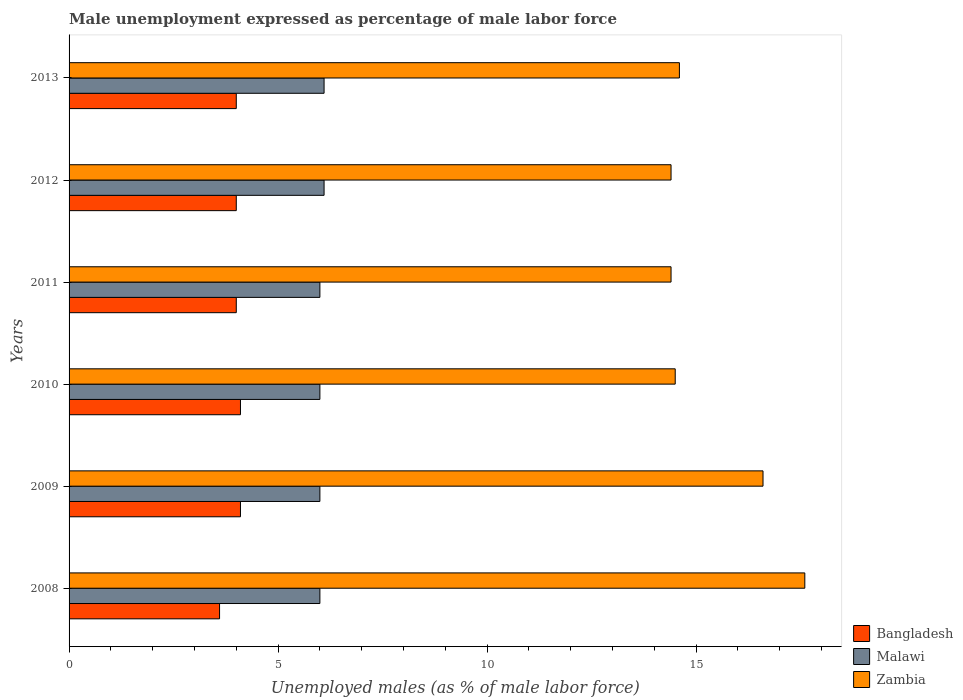How many different coloured bars are there?
Your answer should be very brief. 3. How many groups of bars are there?
Your response must be concise. 6. Are the number of bars on each tick of the Y-axis equal?
Your answer should be very brief. Yes. How many bars are there on the 2nd tick from the bottom?
Your response must be concise. 3. What is the label of the 3rd group of bars from the top?
Provide a short and direct response. 2011. What is the unemployment in males in in Zambia in 2011?
Your answer should be very brief. 14.4. Across all years, what is the maximum unemployment in males in in Zambia?
Your answer should be compact. 17.6. What is the total unemployment in males in in Malawi in the graph?
Your answer should be compact. 36.2. What is the difference between the unemployment in males in in Bangladesh in 2009 and that in 2012?
Provide a short and direct response. 0.1. What is the difference between the unemployment in males in in Malawi in 2010 and the unemployment in males in in Bangladesh in 2011?
Provide a short and direct response. 2. What is the average unemployment in males in in Bangladesh per year?
Offer a terse response. 3.97. In the year 2010, what is the difference between the unemployment in males in in Zambia and unemployment in males in in Malawi?
Ensure brevity in your answer.  8.5. What is the ratio of the unemployment in males in in Malawi in 2010 to that in 2012?
Provide a succinct answer. 0.98. What is the difference between the highest and the lowest unemployment in males in in Bangladesh?
Your answer should be very brief. 0.5. In how many years, is the unemployment in males in in Bangladesh greater than the average unemployment in males in in Bangladesh taken over all years?
Give a very brief answer. 5. Is the sum of the unemployment in males in in Malawi in 2009 and 2010 greater than the maximum unemployment in males in in Bangladesh across all years?
Provide a succinct answer. Yes. What does the 1st bar from the top in 2011 represents?
Your answer should be compact. Zambia. What does the 2nd bar from the bottom in 2011 represents?
Provide a succinct answer. Malawi. How many bars are there?
Offer a very short reply. 18. Are all the bars in the graph horizontal?
Ensure brevity in your answer.  Yes. What is the difference between two consecutive major ticks on the X-axis?
Provide a short and direct response. 5. Does the graph contain any zero values?
Keep it short and to the point. No. Does the graph contain grids?
Offer a very short reply. No. How many legend labels are there?
Make the answer very short. 3. What is the title of the graph?
Offer a terse response. Male unemployment expressed as percentage of male labor force. Does "Guinea" appear as one of the legend labels in the graph?
Your answer should be very brief. No. What is the label or title of the X-axis?
Keep it short and to the point. Unemployed males (as % of male labor force). What is the Unemployed males (as % of male labor force) in Bangladesh in 2008?
Make the answer very short. 3.6. What is the Unemployed males (as % of male labor force) of Malawi in 2008?
Offer a very short reply. 6. What is the Unemployed males (as % of male labor force) of Zambia in 2008?
Keep it short and to the point. 17.6. What is the Unemployed males (as % of male labor force) of Bangladesh in 2009?
Give a very brief answer. 4.1. What is the Unemployed males (as % of male labor force) in Malawi in 2009?
Give a very brief answer. 6. What is the Unemployed males (as % of male labor force) of Zambia in 2009?
Make the answer very short. 16.6. What is the Unemployed males (as % of male labor force) in Bangladesh in 2010?
Your answer should be very brief. 4.1. What is the Unemployed males (as % of male labor force) in Malawi in 2010?
Offer a very short reply. 6. What is the Unemployed males (as % of male labor force) of Zambia in 2010?
Your answer should be very brief. 14.5. What is the Unemployed males (as % of male labor force) of Bangladesh in 2011?
Provide a succinct answer. 4. What is the Unemployed males (as % of male labor force) of Zambia in 2011?
Your answer should be compact. 14.4. What is the Unemployed males (as % of male labor force) of Bangladesh in 2012?
Your answer should be very brief. 4. What is the Unemployed males (as % of male labor force) of Malawi in 2012?
Offer a terse response. 6.1. What is the Unemployed males (as % of male labor force) of Zambia in 2012?
Provide a short and direct response. 14.4. What is the Unemployed males (as % of male labor force) in Bangladesh in 2013?
Ensure brevity in your answer.  4. What is the Unemployed males (as % of male labor force) of Malawi in 2013?
Your answer should be very brief. 6.1. What is the Unemployed males (as % of male labor force) in Zambia in 2013?
Offer a very short reply. 14.6. Across all years, what is the maximum Unemployed males (as % of male labor force) of Bangladesh?
Offer a very short reply. 4.1. Across all years, what is the maximum Unemployed males (as % of male labor force) in Malawi?
Offer a very short reply. 6.1. Across all years, what is the maximum Unemployed males (as % of male labor force) of Zambia?
Your answer should be compact. 17.6. Across all years, what is the minimum Unemployed males (as % of male labor force) of Bangladesh?
Make the answer very short. 3.6. Across all years, what is the minimum Unemployed males (as % of male labor force) in Malawi?
Provide a succinct answer. 6. Across all years, what is the minimum Unemployed males (as % of male labor force) in Zambia?
Offer a terse response. 14.4. What is the total Unemployed males (as % of male labor force) of Bangladesh in the graph?
Make the answer very short. 23.8. What is the total Unemployed males (as % of male labor force) of Malawi in the graph?
Make the answer very short. 36.2. What is the total Unemployed males (as % of male labor force) in Zambia in the graph?
Ensure brevity in your answer.  92.1. What is the difference between the Unemployed males (as % of male labor force) in Malawi in 2008 and that in 2009?
Provide a short and direct response. 0. What is the difference between the Unemployed males (as % of male labor force) of Zambia in 2008 and that in 2009?
Your answer should be very brief. 1. What is the difference between the Unemployed males (as % of male labor force) in Malawi in 2008 and that in 2010?
Offer a very short reply. 0. What is the difference between the Unemployed males (as % of male labor force) of Bangladesh in 2008 and that in 2011?
Ensure brevity in your answer.  -0.4. What is the difference between the Unemployed males (as % of male labor force) of Zambia in 2008 and that in 2011?
Your answer should be very brief. 3.2. What is the difference between the Unemployed males (as % of male labor force) in Bangladesh in 2008 and that in 2012?
Provide a succinct answer. -0.4. What is the difference between the Unemployed males (as % of male labor force) of Malawi in 2008 and that in 2012?
Make the answer very short. -0.1. What is the difference between the Unemployed males (as % of male labor force) of Bangladesh in 2008 and that in 2013?
Your response must be concise. -0.4. What is the difference between the Unemployed males (as % of male labor force) in Bangladesh in 2009 and that in 2011?
Your answer should be very brief. 0.1. What is the difference between the Unemployed males (as % of male labor force) in Malawi in 2009 and that in 2011?
Your answer should be very brief. 0. What is the difference between the Unemployed males (as % of male labor force) in Bangladesh in 2009 and that in 2012?
Ensure brevity in your answer.  0.1. What is the difference between the Unemployed males (as % of male labor force) of Malawi in 2009 and that in 2012?
Keep it short and to the point. -0.1. What is the difference between the Unemployed males (as % of male labor force) in Zambia in 2009 and that in 2012?
Keep it short and to the point. 2.2. What is the difference between the Unemployed males (as % of male labor force) in Bangladesh in 2010 and that in 2011?
Give a very brief answer. 0.1. What is the difference between the Unemployed males (as % of male labor force) in Malawi in 2010 and that in 2011?
Offer a terse response. 0. What is the difference between the Unemployed males (as % of male labor force) in Zambia in 2010 and that in 2011?
Your response must be concise. 0.1. What is the difference between the Unemployed males (as % of male labor force) of Malawi in 2010 and that in 2012?
Give a very brief answer. -0.1. What is the difference between the Unemployed males (as % of male labor force) of Zambia in 2010 and that in 2012?
Make the answer very short. 0.1. What is the difference between the Unemployed males (as % of male labor force) in Malawi in 2010 and that in 2013?
Ensure brevity in your answer.  -0.1. What is the difference between the Unemployed males (as % of male labor force) of Bangladesh in 2011 and that in 2012?
Provide a succinct answer. 0. What is the difference between the Unemployed males (as % of male labor force) in Malawi in 2011 and that in 2012?
Give a very brief answer. -0.1. What is the difference between the Unemployed males (as % of male labor force) in Bangladesh in 2011 and that in 2013?
Give a very brief answer. 0. What is the difference between the Unemployed males (as % of male labor force) in Malawi in 2011 and that in 2013?
Your answer should be compact. -0.1. What is the difference between the Unemployed males (as % of male labor force) of Bangladesh in 2012 and that in 2013?
Provide a succinct answer. 0. What is the difference between the Unemployed males (as % of male labor force) of Zambia in 2012 and that in 2013?
Provide a succinct answer. -0.2. What is the difference between the Unemployed males (as % of male labor force) in Bangladesh in 2008 and the Unemployed males (as % of male labor force) in Zambia in 2009?
Keep it short and to the point. -13. What is the difference between the Unemployed males (as % of male labor force) in Bangladesh in 2008 and the Unemployed males (as % of male labor force) in Zambia in 2010?
Give a very brief answer. -10.9. What is the difference between the Unemployed males (as % of male labor force) of Malawi in 2008 and the Unemployed males (as % of male labor force) of Zambia in 2010?
Provide a short and direct response. -8.5. What is the difference between the Unemployed males (as % of male labor force) of Bangladesh in 2008 and the Unemployed males (as % of male labor force) of Malawi in 2011?
Provide a short and direct response. -2.4. What is the difference between the Unemployed males (as % of male labor force) in Bangladesh in 2008 and the Unemployed males (as % of male labor force) in Zambia in 2011?
Your answer should be very brief. -10.8. What is the difference between the Unemployed males (as % of male labor force) of Bangladesh in 2008 and the Unemployed males (as % of male labor force) of Malawi in 2012?
Provide a short and direct response. -2.5. What is the difference between the Unemployed males (as % of male labor force) of Bangladesh in 2008 and the Unemployed males (as % of male labor force) of Zambia in 2012?
Your response must be concise. -10.8. What is the difference between the Unemployed males (as % of male labor force) in Malawi in 2008 and the Unemployed males (as % of male labor force) in Zambia in 2012?
Offer a very short reply. -8.4. What is the difference between the Unemployed males (as % of male labor force) of Bangladesh in 2008 and the Unemployed males (as % of male labor force) of Malawi in 2013?
Your response must be concise. -2.5. What is the difference between the Unemployed males (as % of male labor force) of Malawi in 2008 and the Unemployed males (as % of male labor force) of Zambia in 2013?
Keep it short and to the point. -8.6. What is the difference between the Unemployed males (as % of male labor force) of Bangladesh in 2009 and the Unemployed males (as % of male labor force) of Malawi in 2010?
Provide a succinct answer. -1.9. What is the difference between the Unemployed males (as % of male labor force) in Malawi in 2009 and the Unemployed males (as % of male labor force) in Zambia in 2010?
Make the answer very short. -8.5. What is the difference between the Unemployed males (as % of male labor force) in Bangladesh in 2009 and the Unemployed males (as % of male labor force) in Malawi in 2011?
Offer a very short reply. -1.9. What is the difference between the Unemployed males (as % of male labor force) in Bangladesh in 2009 and the Unemployed males (as % of male labor force) in Zambia in 2012?
Your response must be concise. -10.3. What is the difference between the Unemployed males (as % of male labor force) of Malawi in 2009 and the Unemployed males (as % of male labor force) of Zambia in 2012?
Make the answer very short. -8.4. What is the difference between the Unemployed males (as % of male labor force) in Bangladesh in 2009 and the Unemployed males (as % of male labor force) in Zambia in 2013?
Your answer should be very brief. -10.5. What is the difference between the Unemployed males (as % of male labor force) of Bangladesh in 2010 and the Unemployed males (as % of male labor force) of Malawi in 2011?
Provide a succinct answer. -1.9. What is the difference between the Unemployed males (as % of male labor force) in Bangladesh in 2010 and the Unemployed males (as % of male labor force) in Zambia in 2011?
Make the answer very short. -10.3. What is the difference between the Unemployed males (as % of male labor force) in Bangladesh in 2010 and the Unemployed males (as % of male labor force) in Malawi in 2012?
Ensure brevity in your answer.  -2. What is the difference between the Unemployed males (as % of male labor force) of Malawi in 2010 and the Unemployed males (as % of male labor force) of Zambia in 2013?
Provide a succinct answer. -8.6. What is the difference between the Unemployed males (as % of male labor force) of Bangladesh in 2011 and the Unemployed males (as % of male labor force) of Malawi in 2013?
Offer a terse response. -2.1. What is the difference between the Unemployed males (as % of male labor force) in Bangladesh in 2011 and the Unemployed males (as % of male labor force) in Zambia in 2013?
Your answer should be compact. -10.6. What is the difference between the Unemployed males (as % of male labor force) of Bangladesh in 2012 and the Unemployed males (as % of male labor force) of Malawi in 2013?
Keep it short and to the point. -2.1. What is the average Unemployed males (as % of male labor force) in Bangladesh per year?
Keep it short and to the point. 3.97. What is the average Unemployed males (as % of male labor force) of Malawi per year?
Your response must be concise. 6.03. What is the average Unemployed males (as % of male labor force) of Zambia per year?
Ensure brevity in your answer.  15.35. In the year 2008, what is the difference between the Unemployed males (as % of male labor force) of Malawi and Unemployed males (as % of male labor force) of Zambia?
Provide a succinct answer. -11.6. In the year 2009, what is the difference between the Unemployed males (as % of male labor force) of Bangladesh and Unemployed males (as % of male labor force) of Zambia?
Your answer should be very brief. -12.5. In the year 2009, what is the difference between the Unemployed males (as % of male labor force) in Malawi and Unemployed males (as % of male labor force) in Zambia?
Give a very brief answer. -10.6. In the year 2010, what is the difference between the Unemployed males (as % of male labor force) of Bangladesh and Unemployed males (as % of male labor force) of Zambia?
Give a very brief answer. -10.4. In the year 2010, what is the difference between the Unemployed males (as % of male labor force) in Malawi and Unemployed males (as % of male labor force) in Zambia?
Offer a very short reply. -8.5. In the year 2012, what is the difference between the Unemployed males (as % of male labor force) of Bangladesh and Unemployed males (as % of male labor force) of Malawi?
Offer a very short reply. -2.1. In the year 2013, what is the difference between the Unemployed males (as % of male labor force) in Bangladesh and Unemployed males (as % of male labor force) in Malawi?
Offer a terse response. -2.1. In the year 2013, what is the difference between the Unemployed males (as % of male labor force) of Bangladesh and Unemployed males (as % of male labor force) of Zambia?
Keep it short and to the point. -10.6. In the year 2013, what is the difference between the Unemployed males (as % of male labor force) in Malawi and Unemployed males (as % of male labor force) in Zambia?
Ensure brevity in your answer.  -8.5. What is the ratio of the Unemployed males (as % of male labor force) of Bangladesh in 2008 to that in 2009?
Offer a very short reply. 0.88. What is the ratio of the Unemployed males (as % of male labor force) in Malawi in 2008 to that in 2009?
Your answer should be compact. 1. What is the ratio of the Unemployed males (as % of male labor force) of Zambia in 2008 to that in 2009?
Your answer should be compact. 1.06. What is the ratio of the Unemployed males (as % of male labor force) in Bangladesh in 2008 to that in 2010?
Your answer should be very brief. 0.88. What is the ratio of the Unemployed males (as % of male labor force) of Zambia in 2008 to that in 2010?
Ensure brevity in your answer.  1.21. What is the ratio of the Unemployed males (as % of male labor force) in Zambia in 2008 to that in 2011?
Give a very brief answer. 1.22. What is the ratio of the Unemployed males (as % of male labor force) of Bangladesh in 2008 to that in 2012?
Your answer should be very brief. 0.9. What is the ratio of the Unemployed males (as % of male labor force) in Malawi in 2008 to that in 2012?
Keep it short and to the point. 0.98. What is the ratio of the Unemployed males (as % of male labor force) of Zambia in 2008 to that in 2012?
Your answer should be compact. 1.22. What is the ratio of the Unemployed males (as % of male labor force) in Malawi in 2008 to that in 2013?
Provide a succinct answer. 0.98. What is the ratio of the Unemployed males (as % of male labor force) in Zambia in 2008 to that in 2013?
Provide a succinct answer. 1.21. What is the ratio of the Unemployed males (as % of male labor force) in Malawi in 2009 to that in 2010?
Your response must be concise. 1. What is the ratio of the Unemployed males (as % of male labor force) in Zambia in 2009 to that in 2010?
Offer a terse response. 1.14. What is the ratio of the Unemployed males (as % of male labor force) in Malawi in 2009 to that in 2011?
Your answer should be very brief. 1. What is the ratio of the Unemployed males (as % of male labor force) in Zambia in 2009 to that in 2011?
Offer a very short reply. 1.15. What is the ratio of the Unemployed males (as % of male labor force) in Bangladesh in 2009 to that in 2012?
Keep it short and to the point. 1.02. What is the ratio of the Unemployed males (as % of male labor force) of Malawi in 2009 to that in 2012?
Keep it short and to the point. 0.98. What is the ratio of the Unemployed males (as % of male labor force) in Zambia in 2009 to that in 2012?
Make the answer very short. 1.15. What is the ratio of the Unemployed males (as % of male labor force) in Malawi in 2009 to that in 2013?
Offer a very short reply. 0.98. What is the ratio of the Unemployed males (as % of male labor force) in Zambia in 2009 to that in 2013?
Your answer should be compact. 1.14. What is the ratio of the Unemployed males (as % of male labor force) of Bangladesh in 2010 to that in 2011?
Your answer should be very brief. 1.02. What is the ratio of the Unemployed males (as % of male labor force) in Zambia in 2010 to that in 2011?
Your answer should be very brief. 1.01. What is the ratio of the Unemployed males (as % of male labor force) in Bangladesh in 2010 to that in 2012?
Provide a short and direct response. 1.02. What is the ratio of the Unemployed males (as % of male labor force) of Malawi in 2010 to that in 2012?
Provide a succinct answer. 0.98. What is the ratio of the Unemployed males (as % of male labor force) of Zambia in 2010 to that in 2012?
Your answer should be compact. 1.01. What is the ratio of the Unemployed males (as % of male labor force) in Bangladesh in 2010 to that in 2013?
Offer a very short reply. 1.02. What is the ratio of the Unemployed males (as % of male labor force) in Malawi in 2010 to that in 2013?
Keep it short and to the point. 0.98. What is the ratio of the Unemployed males (as % of male labor force) of Zambia in 2010 to that in 2013?
Give a very brief answer. 0.99. What is the ratio of the Unemployed males (as % of male labor force) in Malawi in 2011 to that in 2012?
Offer a very short reply. 0.98. What is the ratio of the Unemployed males (as % of male labor force) in Zambia in 2011 to that in 2012?
Your response must be concise. 1. What is the ratio of the Unemployed males (as % of male labor force) of Malawi in 2011 to that in 2013?
Give a very brief answer. 0.98. What is the ratio of the Unemployed males (as % of male labor force) of Zambia in 2011 to that in 2013?
Offer a very short reply. 0.99. What is the ratio of the Unemployed males (as % of male labor force) in Zambia in 2012 to that in 2013?
Offer a very short reply. 0.99. What is the difference between the highest and the second highest Unemployed males (as % of male labor force) in Bangladesh?
Ensure brevity in your answer.  0. What is the difference between the highest and the lowest Unemployed males (as % of male labor force) of Zambia?
Your answer should be compact. 3.2. 